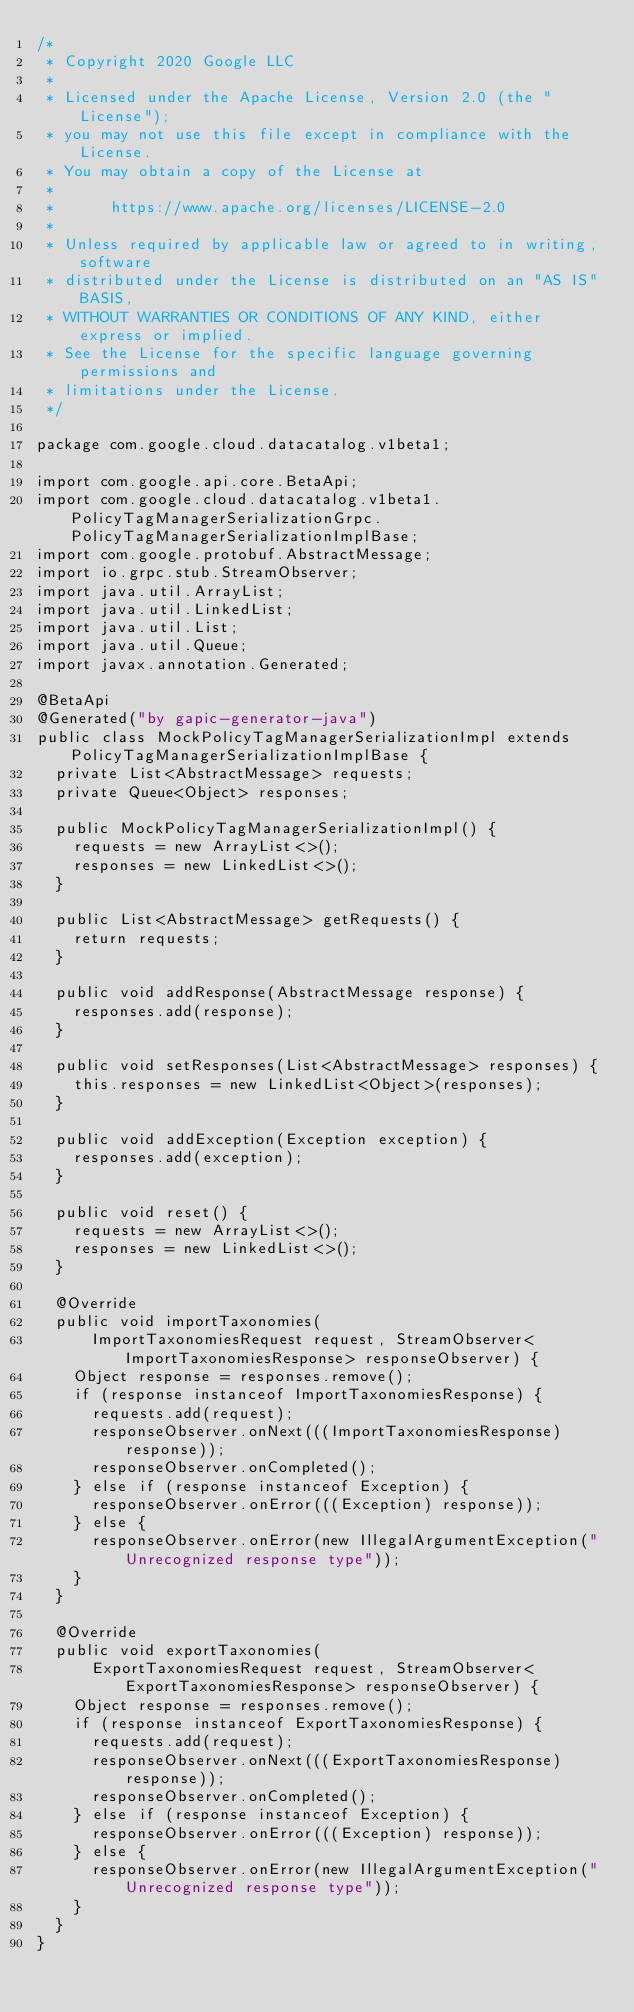<code> <loc_0><loc_0><loc_500><loc_500><_Java_>/*
 * Copyright 2020 Google LLC
 *
 * Licensed under the Apache License, Version 2.0 (the "License");
 * you may not use this file except in compliance with the License.
 * You may obtain a copy of the License at
 *
 *      https://www.apache.org/licenses/LICENSE-2.0
 *
 * Unless required by applicable law or agreed to in writing, software
 * distributed under the License is distributed on an "AS IS" BASIS,
 * WITHOUT WARRANTIES OR CONDITIONS OF ANY KIND, either express or implied.
 * See the License for the specific language governing permissions and
 * limitations under the License.
 */

package com.google.cloud.datacatalog.v1beta1;

import com.google.api.core.BetaApi;
import com.google.cloud.datacatalog.v1beta1.PolicyTagManagerSerializationGrpc.PolicyTagManagerSerializationImplBase;
import com.google.protobuf.AbstractMessage;
import io.grpc.stub.StreamObserver;
import java.util.ArrayList;
import java.util.LinkedList;
import java.util.List;
import java.util.Queue;
import javax.annotation.Generated;

@BetaApi
@Generated("by gapic-generator-java")
public class MockPolicyTagManagerSerializationImpl extends PolicyTagManagerSerializationImplBase {
  private List<AbstractMessage> requests;
  private Queue<Object> responses;

  public MockPolicyTagManagerSerializationImpl() {
    requests = new ArrayList<>();
    responses = new LinkedList<>();
  }

  public List<AbstractMessage> getRequests() {
    return requests;
  }

  public void addResponse(AbstractMessage response) {
    responses.add(response);
  }

  public void setResponses(List<AbstractMessage> responses) {
    this.responses = new LinkedList<Object>(responses);
  }

  public void addException(Exception exception) {
    responses.add(exception);
  }

  public void reset() {
    requests = new ArrayList<>();
    responses = new LinkedList<>();
  }

  @Override
  public void importTaxonomies(
      ImportTaxonomiesRequest request, StreamObserver<ImportTaxonomiesResponse> responseObserver) {
    Object response = responses.remove();
    if (response instanceof ImportTaxonomiesResponse) {
      requests.add(request);
      responseObserver.onNext(((ImportTaxonomiesResponse) response));
      responseObserver.onCompleted();
    } else if (response instanceof Exception) {
      responseObserver.onError(((Exception) response));
    } else {
      responseObserver.onError(new IllegalArgumentException("Unrecognized response type"));
    }
  }

  @Override
  public void exportTaxonomies(
      ExportTaxonomiesRequest request, StreamObserver<ExportTaxonomiesResponse> responseObserver) {
    Object response = responses.remove();
    if (response instanceof ExportTaxonomiesResponse) {
      requests.add(request);
      responseObserver.onNext(((ExportTaxonomiesResponse) response));
      responseObserver.onCompleted();
    } else if (response instanceof Exception) {
      responseObserver.onError(((Exception) response));
    } else {
      responseObserver.onError(new IllegalArgumentException("Unrecognized response type"));
    }
  }
}
</code> 